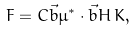<formula> <loc_0><loc_0><loc_500><loc_500>F = C \vec { b } \mu ^ { * } \cdot \vec { b } { H } \, K ,</formula> 